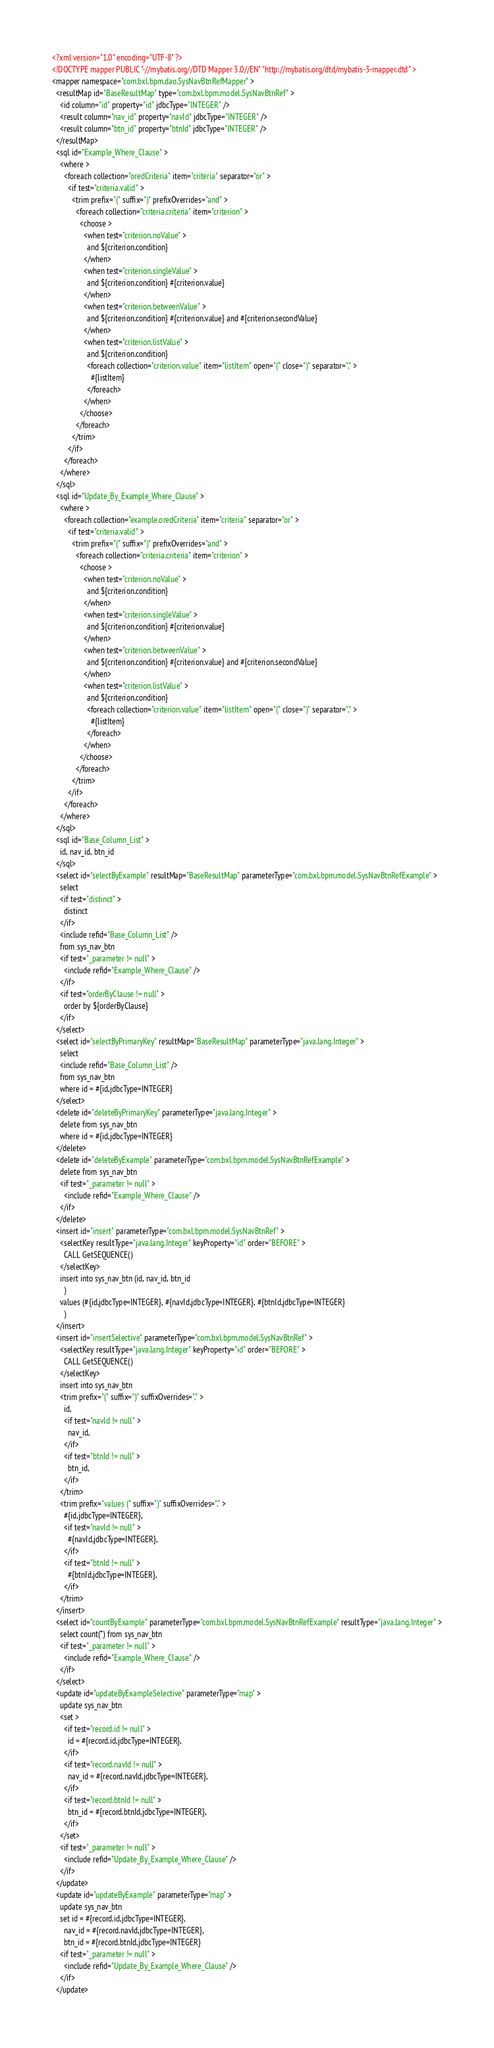Convert code to text. <code><loc_0><loc_0><loc_500><loc_500><_XML_><?xml version="1.0" encoding="UTF-8" ?>
<!DOCTYPE mapper PUBLIC "-//mybatis.org//DTD Mapper 3.0//EN" "http://mybatis.org/dtd/mybatis-3-mapper.dtd" >
<mapper namespace="com.bxl.bpm.dao.SysNavBtnRefMapper" >
  <resultMap id="BaseResultMap" type="com.bxl.bpm.model.SysNavBtnRef" >
    <id column="id" property="id" jdbcType="INTEGER" />
    <result column="nav_id" property="navId" jdbcType="INTEGER" />
    <result column="btn_id" property="btnId" jdbcType="INTEGER" />
  </resultMap>
  <sql id="Example_Where_Clause" >
    <where >
      <foreach collection="oredCriteria" item="criteria" separator="or" >
        <if test="criteria.valid" >
          <trim prefix="(" suffix=")" prefixOverrides="and" >
            <foreach collection="criteria.criteria" item="criterion" >
              <choose >
                <when test="criterion.noValue" >
                  and ${criterion.condition}
                </when>
                <when test="criterion.singleValue" >
                  and ${criterion.condition} #{criterion.value}
                </when>
                <when test="criterion.betweenValue" >
                  and ${criterion.condition} #{criterion.value} and #{criterion.secondValue}
                </when>
                <when test="criterion.listValue" >
                  and ${criterion.condition}
                  <foreach collection="criterion.value" item="listItem" open="(" close=")" separator="," >
                    #{listItem}
                  </foreach>
                </when>
              </choose>
            </foreach>
          </trim>
        </if>
      </foreach>
    </where>
  </sql>
  <sql id="Update_By_Example_Where_Clause" >
    <where >
      <foreach collection="example.oredCriteria" item="criteria" separator="or" >
        <if test="criteria.valid" >
          <trim prefix="(" suffix=")" prefixOverrides="and" >
            <foreach collection="criteria.criteria" item="criterion" >
              <choose >
                <when test="criterion.noValue" >
                  and ${criterion.condition}
                </when>
                <when test="criterion.singleValue" >
                  and ${criterion.condition} #{criterion.value}
                </when>
                <when test="criterion.betweenValue" >
                  and ${criterion.condition} #{criterion.value} and #{criterion.secondValue}
                </when>
                <when test="criterion.listValue" >
                  and ${criterion.condition}
                  <foreach collection="criterion.value" item="listItem" open="(" close=")" separator="," >
                    #{listItem}
                  </foreach>
                </when>
              </choose>
            </foreach>
          </trim>
        </if>
      </foreach>
    </where>
  </sql>
  <sql id="Base_Column_List" >
    id, nav_id, btn_id
  </sql>
  <select id="selectByExample" resultMap="BaseResultMap" parameterType="com.bxl.bpm.model.SysNavBtnRefExample" >
    select
    <if test="distinct" >
      distinct
    </if>
    <include refid="Base_Column_List" />
    from sys_nav_btn
    <if test="_parameter != null" >
      <include refid="Example_Where_Clause" />
    </if>
    <if test="orderByClause != null" >
      order by ${orderByClause}
    </if>
  </select>
  <select id="selectByPrimaryKey" resultMap="BaseResultMap" parameterType="java.lang.Integer" >
    select 
    <include refid="Base_Column_List" />
    from sys_nav_btn
    where id = #{id,jdbcType=INTEGER}
  </select>
  <delete id="deleteByPrimaryKey" parameterType="java.lang.Integer" >
    delete from sys_nav_btn
    where id = #{id,jdbcType=INTEGER}
  </delete>
  <delete id="deleteByExample" parameterType="com.bxl.bpm.model.SysNavBtnRefExample" >
    delete from sys_nav_btn
    <if test="_parameter != null" >
      <include refid="Example_Where_Clause" />
    </if>
  </delete>
  <insert id="insert" parameterType="com.bxl.bpm.model.SysNavBtnRef" >
    <selectKey resultType="java.lang.Integer" keyProperty="id" order="BEFORE" >
      CALL GetSEQUENCE()
    </selectKey>
    insert into sys_nav_btn (id, nav_id, btn_id
      )
    values (#{id,jdbcType=INTEGER}, #{navId,jdbcType=INTEGER}, #{btnId,jdbcType=INTEGER}
      )
  </insert>
  <insert id="insertSelective" parameterType="com.bxl.bpm.model.SysNavBtnRef" >
    <selectKey resultType="java.lang.Integer" keyProperty="id" order="BEFORE" >
      CALL GetSEQUENCE()
    </selectKey>
    insert into sys_nav_btn
    <trim prefix="(" suffix=")" suffixOverrides="," >
      id,
      <if test="navId != null" >
        nav_id,
      </if>
      <if test="btnId != null" >
        btn_id,
      </if>
    </trim>
    <trim prefix="values (" suffix=")" suffixOverrides="," >
      #{id,jdbcType=INTEGER},
      <if test="navId != null" >
        #{navId,jdbcType=INTEGER},
      </if>
      <if test="btnId != null" >
        #{btnId,jdbcType=INTEGER},
      </if>
    </trim>
  </insert>
  <select id="countByExample" parameterType="com.bxl.bpm.model.SysNavBtnRefExample" resultType="java.lang.Integer" >
    select count(*) from sys_nav_btn
    <if test="_parameter != null" >
      <include refid="Example_Where_Clause" />
    </if>
  </select>
  <update id="updateByExampleSelective" parameterType="map" >
    update sys_nav_btn
    <set >
      <if test="record.id != null" >
        id = #{record.id,jdbcType=INTEGER},
      </if>
      <if test="record.navId != null" >
        nav_id = #{record.navId,jdbcType=INTEGER},
      </if>
      <if test="record.btnId != null" >
        btn_id = #{record.btnId,jdbcType=INTEGER},
      </if>
    </set>
    <if test="_parameter != null" >
      <include refid="Update_By_Example_Where_Clause" />
    </if>
  </update>
  <update id="updateByExample" parameterType="map" >
    update sys_nav_btn
    set id = #{record.id,jdbcType=INTEGER},
      nav_id = #{record.navId,jdbcType=INTEGER},
      btn_id = #{record.btnId,jdbcType=INTEGER}
    <if test="_parameter != null" >
      <include refid="Update_By_Example_Where_Clause" />
    </if>
  </update></code> 